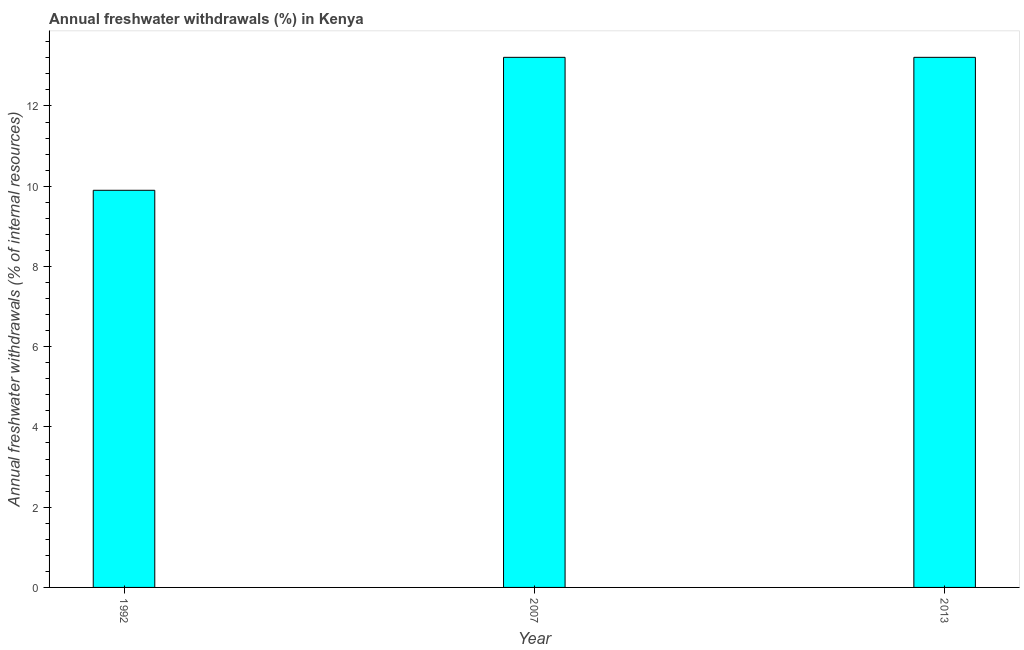What is the title of the graph?
Offer a very short reply. Annual freshwater withdrawals (%) in Kenya. What is the label or title of the Y-axis?
Provide a succinct answer. Annual freshwater withdrawals (% of internal resources). What is the annual freshwater withdrawals in 1992?
Offer a terse response. 9.9. Across all years, what is the maximum annual freshwater withdrawals?
Your response must be concise. 13.21. Across all years, what is the minimum annual freshwater withdrawals?
Your answer should be compact. 9.9. In which year was the annual freshwater withdrawals minimum?
Offer a terse response. 1992. What is the sum of the annual freshwater withdrawals?
Offer a terse response. 36.32. What is the difference between the annual freshwater withdrawals in 2007 and 2013?
Your answer should be compact. 0. What is the average annual freshwater withdrawals per year?
Provide a short and direct response. 12.11. What is the median annual freshwater withdrawals?
Your answer should be compact. 13.21. In how many years, is the annual freshwater withdrawals greater than 2.8 %?
Keep it short and to the point. 3. Do a majority of the years between 2007 and 2013 (inclusive) have annual freshwater withdrawals greater than 4.4 %?
Ensure brevity in your answer.  Yes. What is the ratio of the annual freshwater withdrawals in 2007 to that in 2013?
Your answer should be very brief. 1. Is the difference between the annual freshwater withdrawals in 1992 and 2007 greater than the difference between any two years?
Provide a succinct answer. Yes. What is the difference between the highest and the second highest annual freshwater withdrawals?
Make the answer very short. 0. What is the difference between the highest and the lowest annual freshwater withdrawals?
Offer a very short reply. 3.31. In how many years, is the annual freshwater withdrawals greater than the average annual freshwater withdrawals taken over all years?
Provide a succinct answer. 2. Are all the bars in the graph horizontal?
Make the answer very short. No. How many years are there in the graph?
Ensure brevity in your answer.  3. What is the Annual freshwater withdrawals (% of internal resources) in 1992?
Your response must be concise. 9.9. What is the Annual freshwater withdrawals (% of internal resources) of 2007?
Make the answer very short. 13.21. What is the Annual freshwater withdrawals (% of internal resources) in 2013?
Provide a succinct answer. 13.21. What is the difference between the Annual freshwater withdrawals (% of internal resources) in 1992 and 2007?
Ensure brevity in your answer.  -3.31. What is the difference between the Annual freshwater withdrawals (% of internal resources) in 1992 and 2013?
Offer a terse response. -3.31. What is the difference between the Annual freshwater withdrawals (% of internal resources) in 2007 and 2013?
Offer a very short reply. 0. What is the ratio of the Annual freshwater withdrawals (% of internal resources) in 1992 to that in 2007?
Keep it short and to the point. 0.75. What is the ratio of the Annual freshwater withdrawals (% of internal resources) in 1992 to that in 2013?
Make the answer very short. 0.75. 